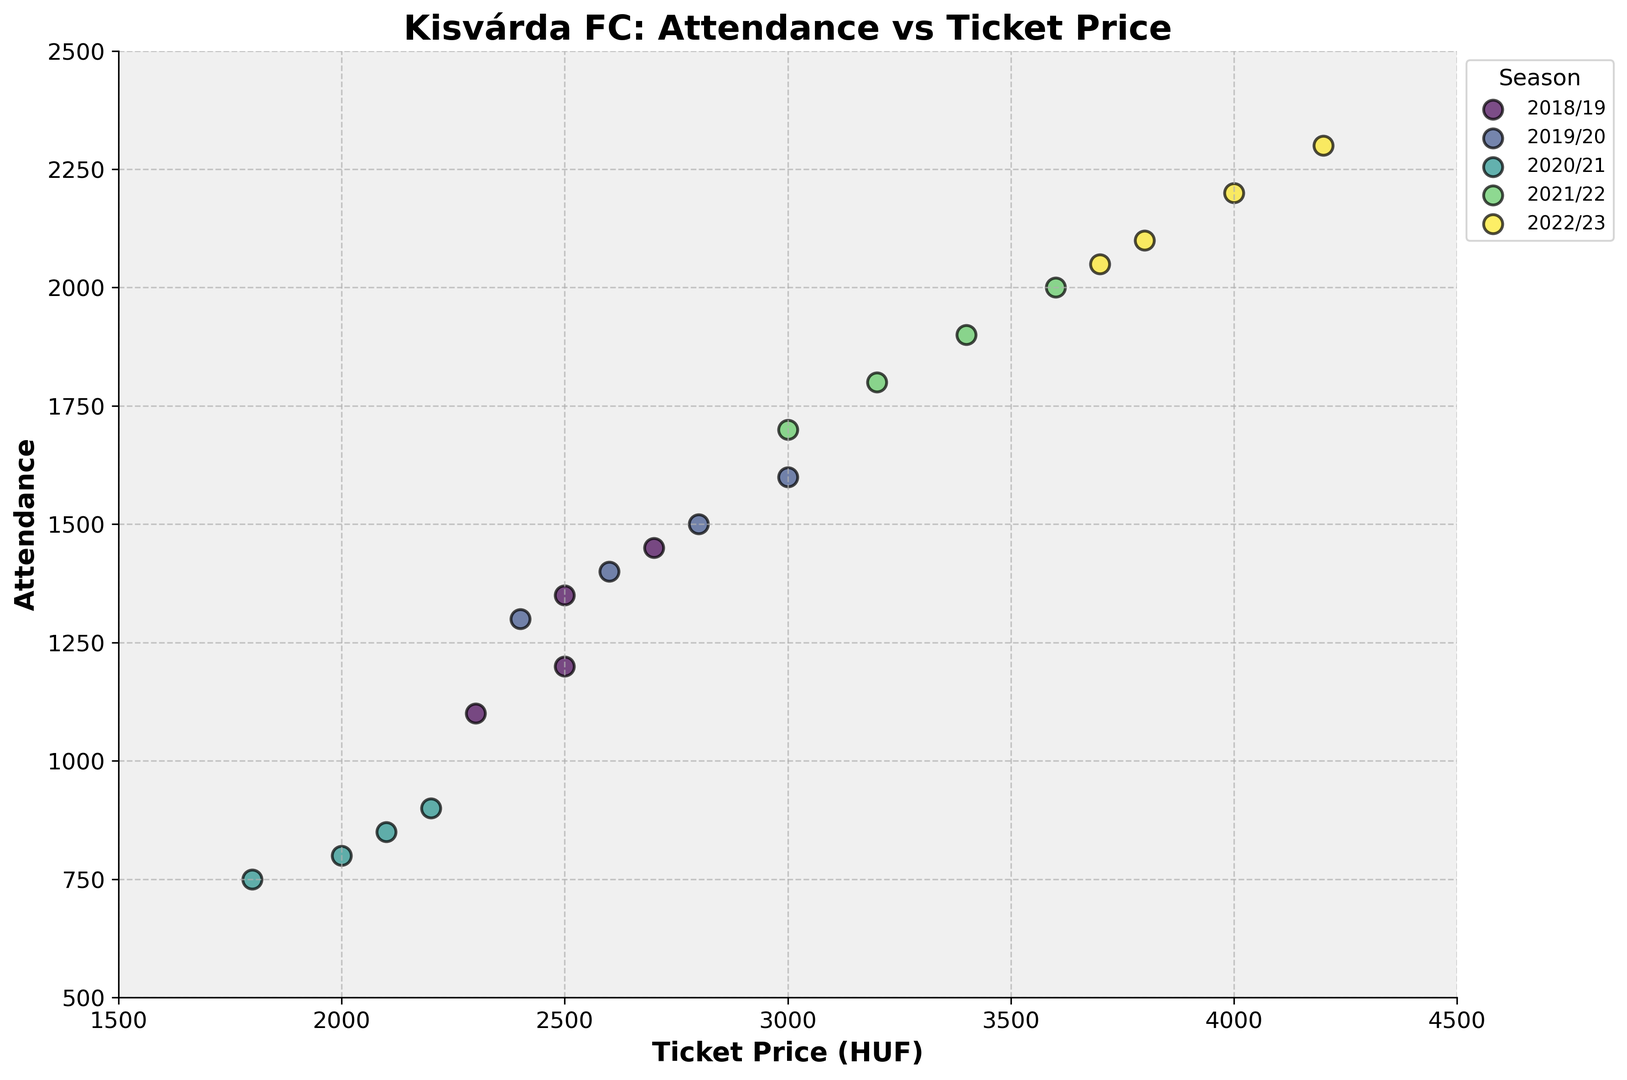What is the general trend in attendance when ticket prices increase across seasons? By examining the scatter plot, there is a visible upward trend where higher ticket prices correspond with higher attendance figures, especially noticeable in the more recent seasons.
Answer: Higher ticket prices generally correlate with higher attendance Which season had the lowest attendance figures and what were the ticket prices in that season? The 2020/21 season had the lowest attendance figures, ranging from 750 to 900. The ticket prices were between 1800 and 2200 HUF.
Answer: 2020/21; 1800-2200 HUF Which season had the highest ticket price and what was the corresponding attendance? The 2022/23 season had the highest ticket price at 4200 HUF, with a corresponding attendance of 2300.
Answer: 2022/23; 2300 Compare the highest attendances between the 2018/19 and 2022/23 seasons. In the 2018/19 season, the highest attendance was 1450, while in the 2022/23 season, it was 2300. Thus, the highest attendance in 2022/23 was significantly higher.
Answer: 2300 in 2022/23 is higher than 1450 in 2018/19 What is the range of ticket prices in the 2019/20 season, and how does it compare to the 2021/22 season? The 2019/20 season had a ticket price range from 2400 to 3000 HUF. In contrast, the 2021/22 season had a range from 3000 to 3600 HUF. This shows an increase in the range of ticket prices over time.
Answer: 2400-3000 HUF in 2019/20; 3000-3600 HUF in 2021/22 Which data points (season) stood out as outliers in terms of attendance, and what were their ticket prices? In the 2020/21 season, the attendance data points ranged from 750 to 900, which are significantly lower compared to other seasons. Their ticket prices ranged from 1800 to 2200 HUF.
Answer: 2020/21; 1800-2200 HUF Identify the season with the most stable (least variable) attendance levels. What are the attendance figures and ticket prices for that season? The 2020/21 season shows the least variability in attendance, with figures mostly between 750 and 900. Corresponding ticket prices were between 1800 and 2200 HUF.
Answer: 2020/21; 750-900 attendance What is the difference in the highest attendance between the 2018/19 and 2020/21 seasons? In the 2018/19 season, the highest attendance was 1450, while in the 2020/21 season, it was 900. The difference is 1450 - 900 = 550.
Answer: 550 How does the median ticket price in the 2022/23 season compare to the median ticket price in the 2019/20 season? The median ticket price in the 2022/23 season is 3900 HUF, while in the 2019/20 season, it is 2700 HUF. The 2022/23 median is higher by 1200 HUF.
Answer: 3900 HUF in 2022/23 is higher than 2700 HUF in 2019/20 